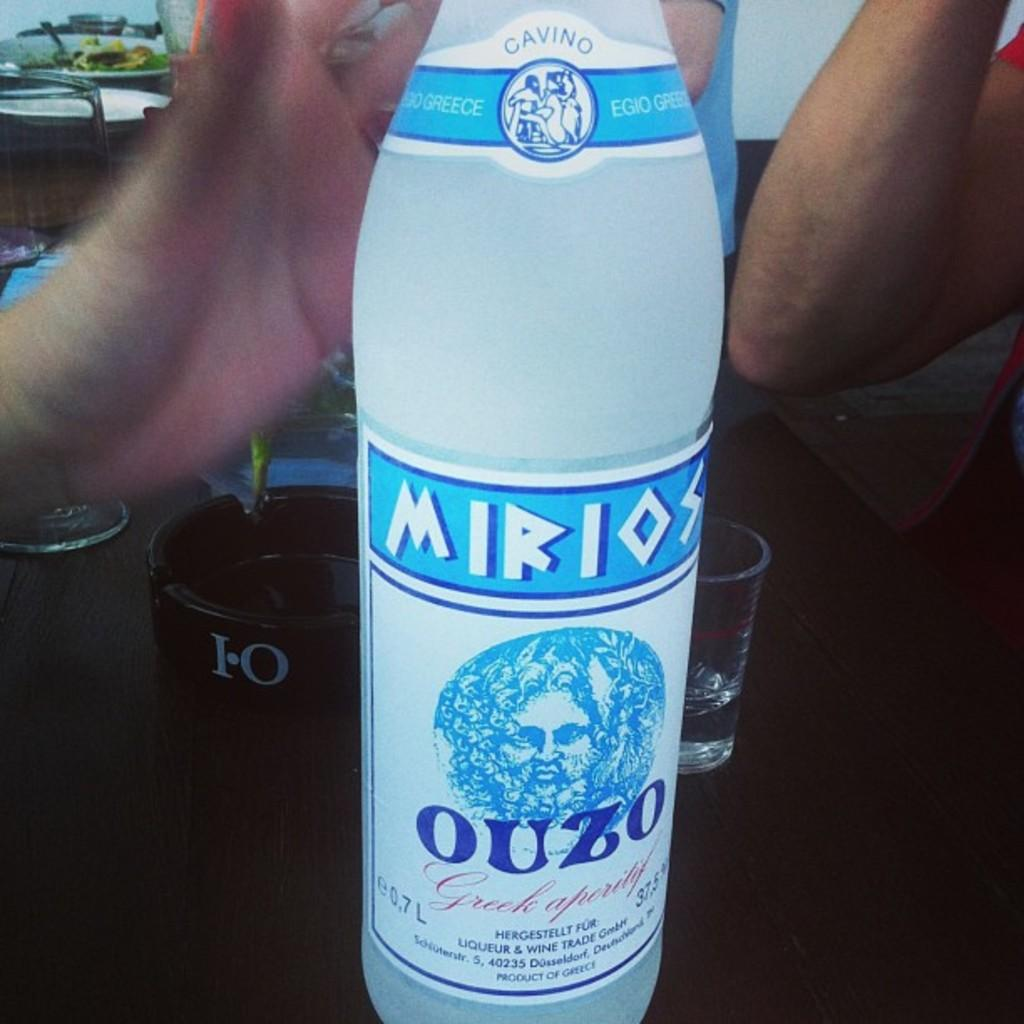<image>
Relay a brief, clear account of the picture shown. A bottle of Mirios Ouzo Greek liquor on a table top 